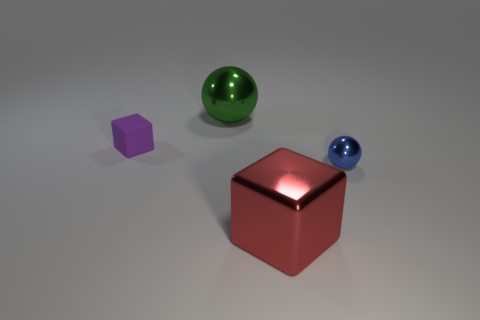Add 3 tiny metallic objects. How many objects exist? 7 Add 2 rubber things. How many rubber things exist? 3 Subtract 0 blue cylinders. How many objects are left? 4 Subtract all brown rubber spheres. Subtract all red shiny things. How many objects are left? 3 Add 1 rubber blocks. How many rubber blocks are left? 2 